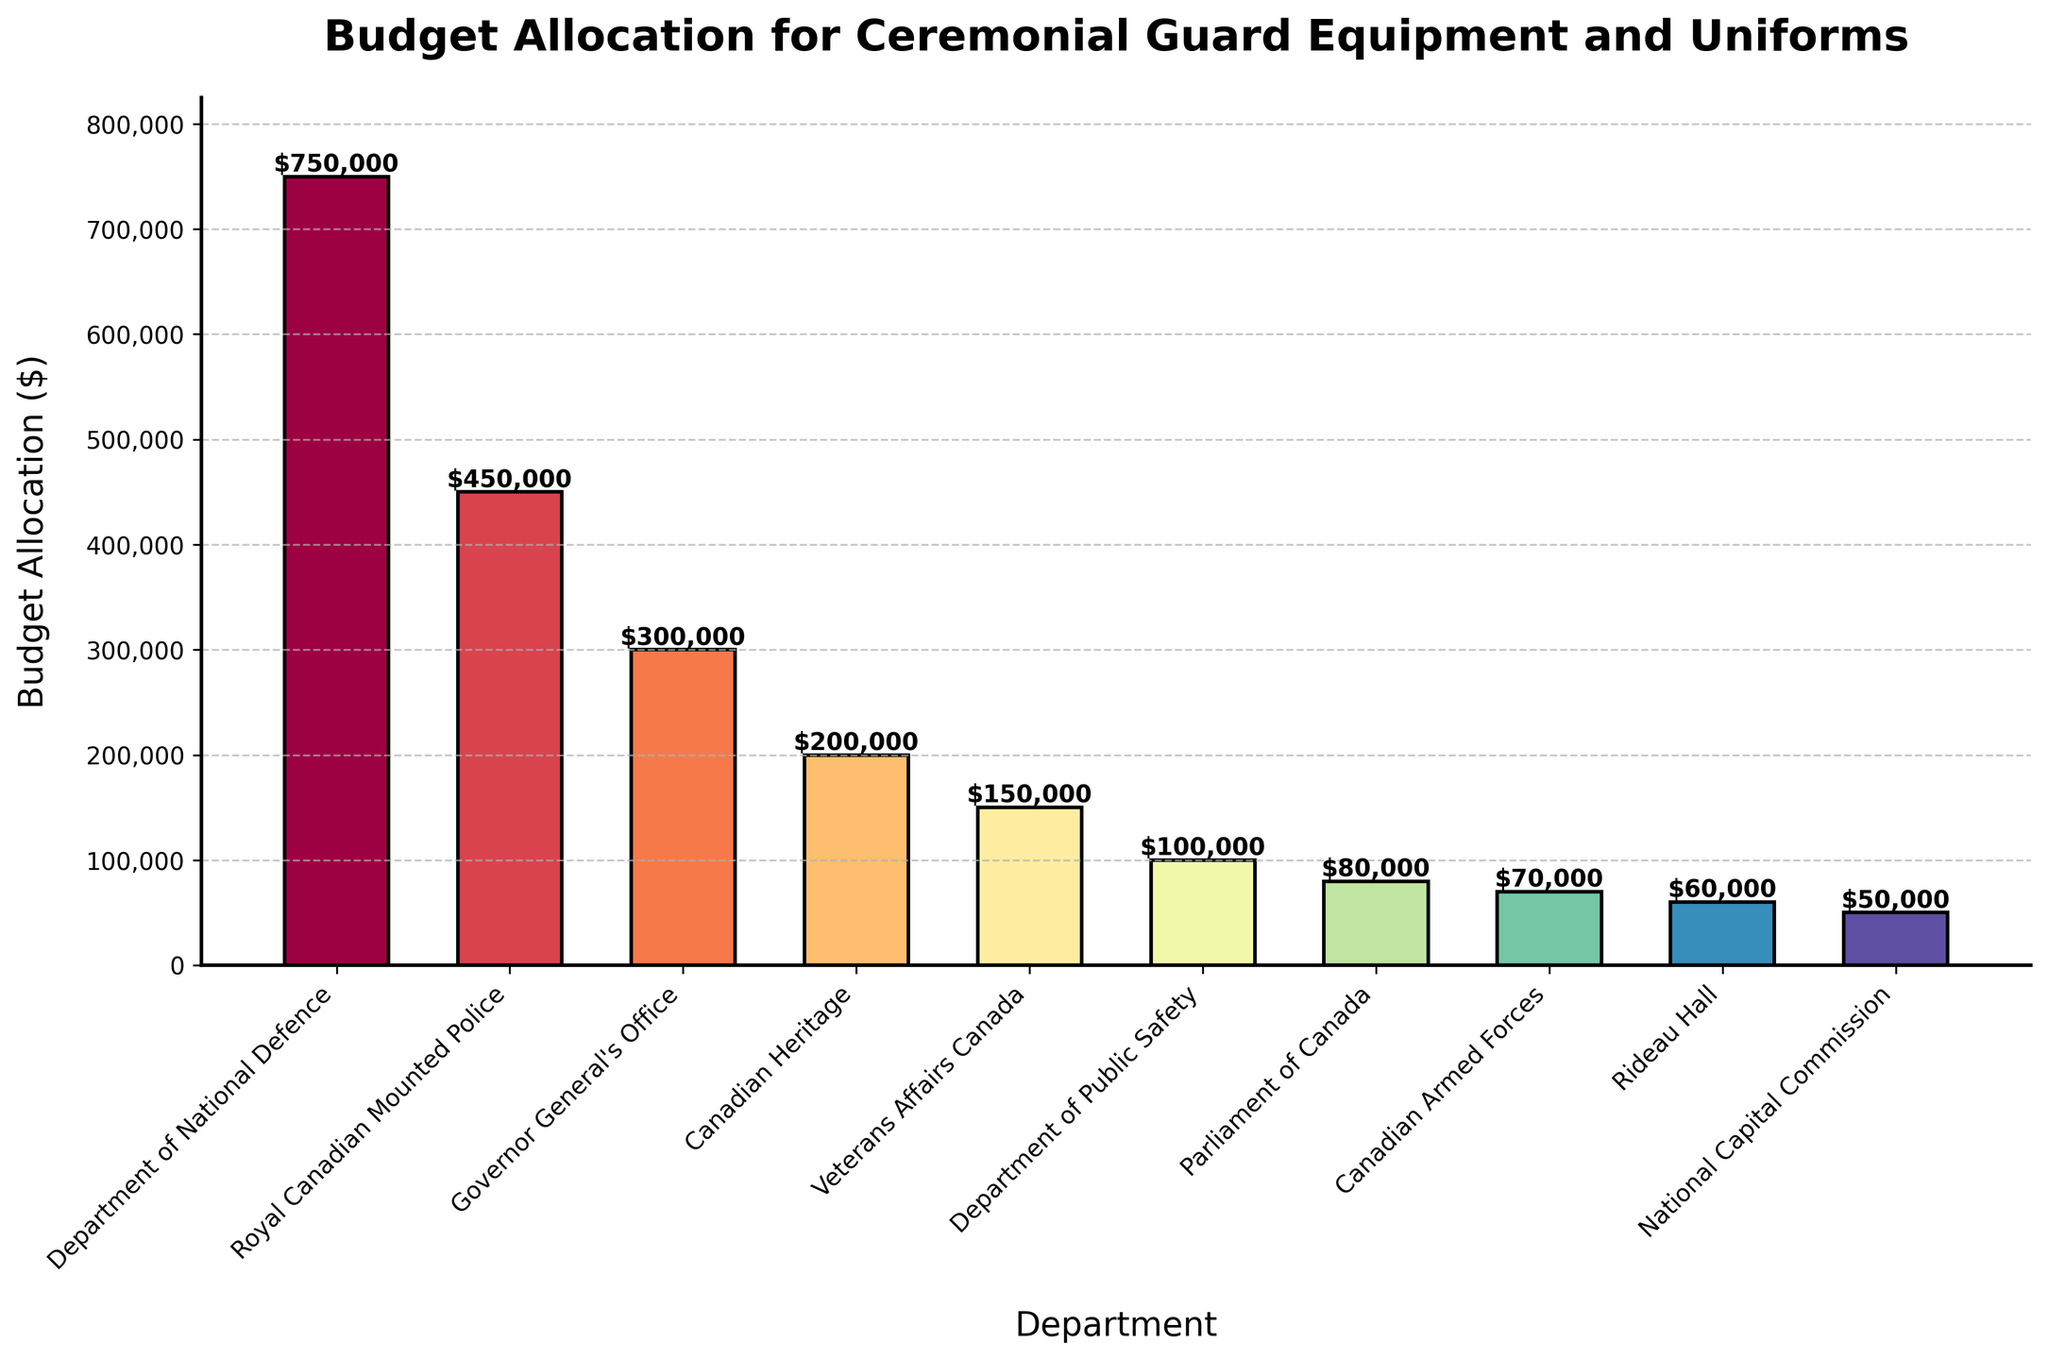What is the total budget allocation for the Royal Canadian Mounted Police and Veterans Affairs Canada? Add the budget allocation for Royal Canadian Mounted Police ($450,000) and Veterans Affairs Canada ($150,000): 450,000 + 150,000 = 600,000
Answer: $600,000 Which department has the lowest budget allocation? Look at the heights of the bars and identify the shortest one; hence the department with the lowest budget allocation. The National Capital Commission bar is the shortest.
Answer: National Capital Commission How much higher is the budget allocation for the Department of National Defence compared to Rideau Hall? Subtract the budget allocation of Rideau Hall ($60,000) from the budget of the Department of National Defence ($750,000): 750,000 - 60,000 = 690,000
Answer: $690,000 Which three departments have the highest budget allocations? Identify the three tallest bars by comparing their heights. The top three are the Department of National Defence, the Royal Canadian Mounted Police, and the Governor General's Office.
Answer: Department of National Defence, Royal Canadian Mounted Police, Governor General's Office What is the average budget allocation across all departments? Sum up the budget allocations for all departments and divide by the number of departments: (750,000 + 450,000 + 300,000 + 200,000 + 150,000 + 100,000 + 80,000 + 70,000 + 60,000 + 50,000) / 10 = 2,210,000 / 10 = 221,000
Answer: $221,000 Which departments have a budget allocation greater than $100,000? Identify the departments with bars taller than the $100,000 mark. They are the Department of National Defence, Royal Canadian Mounted Police, Governor General's Office, Canadian Heritage, and Veterans Affairs Canada.
Answer: Department of National Defence, Royal Canadian Mounted Police, Governor General's Office, Canadian Heritage, Veterans Affairs Canada What is the combined budget allocation for departments with an allocation below $100,000? Sum up the budget allocations of the Parliament of Canada, Canadian Armed Forces, Rideau Hall, and National Capital Commission: 80,000 + 70,000 + 60,000 + 50,000 = 260,000
Answer: $260,000 How many departments have a budget allocation of $200,000 or more? Count the number of departments with bars equal to or taller than the $200,000 mark. They are the Department of National Defence, Royal Canadian Mounted Police, Governor General's Office, and Canadian Heritage.
Answer: 4 